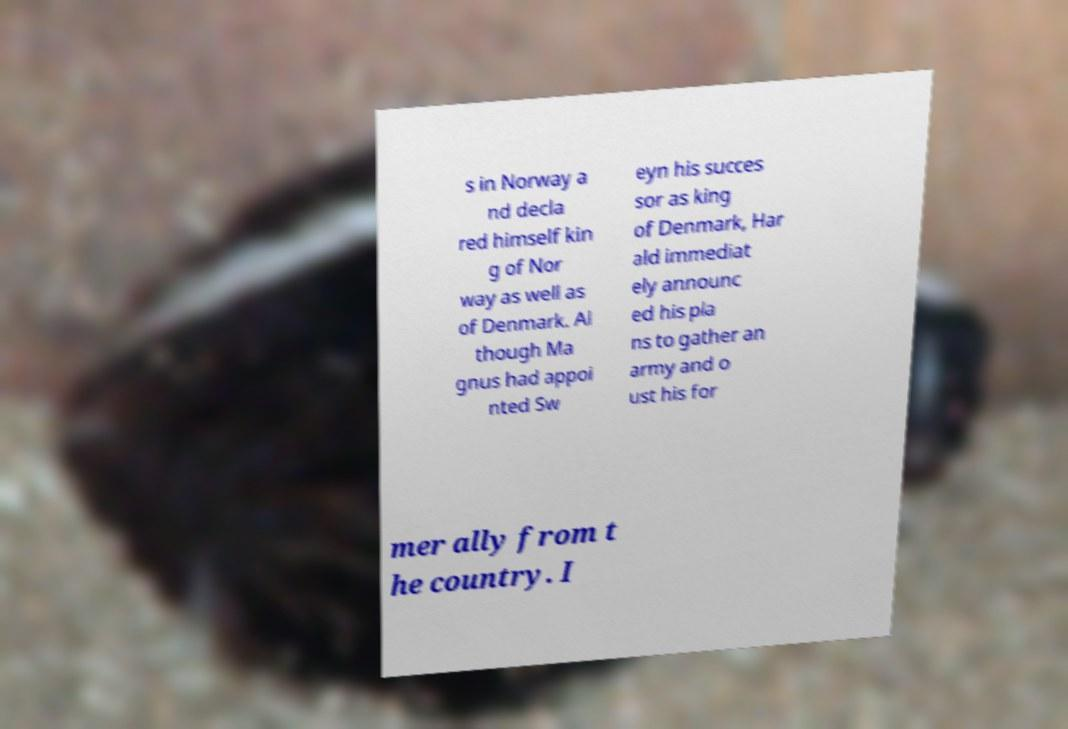What messages or text are displayed in this image? I need them in a readable, typed format. s in Norway a nd decla red himself kin g of Nor way as well as of Denmark. Al though Ma gnus had appoi nted Sw eyn his succes sor as king of Denmark, Har ald immediat ely announc ed his pla ns to gather an army and o ust his for mer ally from t he country. I 